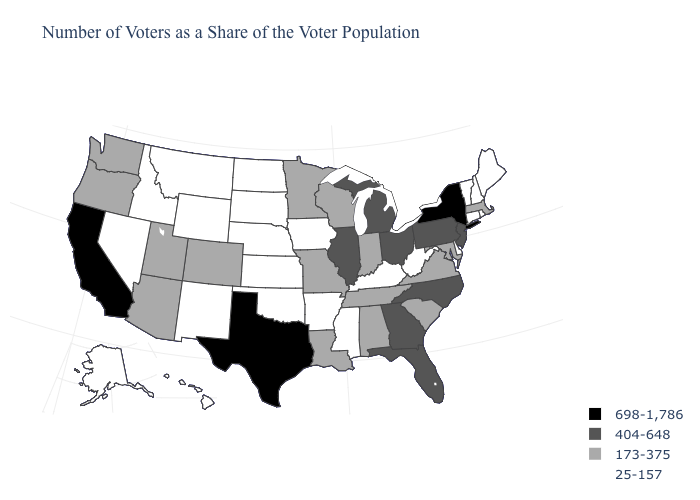Among the states that border Connecticut , which have the lowest value?
Keep it brief. Rhode Island. What is the value of Maryland?
Answer briefly. 173-375. Name the states that have a value in the range 404-648?
Quick response, please. Florida, Georgia, Illinois, Michigan, New Jersey, North Carolina, Ohio, Pennsylvania. Does Kentucky have a higher value than Iowa?
Be succinct. No. What is the highest value in the USA?
Keep it brief. 698-1,786. What is the lowest value in the Northeast?
Be succinct. 25-157. Among the states that border Arizona , which have the highest value?
Answer briefly. California. What is the highest value in states that border Oregon?
Quick response, please. 698-1,786. What is the value of Vermont?
Short answer required. 25-157. Name the states that have a value in the range 25-157?
Answer briefly. Alaska, Arkansas, Connecticut, Delaware, Hawaii, Idaho, Iowa, Kansas, Kentucky, Maine, Mississippi, Montana, Nebraska, Nevada, New Hampshire, New Mexico, North Dakota, Oklahoma, Rhode Island, South Dakota, Vermont, West Virginia, Wyoming. Does the map have missing data?
Write a very short answer. No. Does Michigan have the highest value in the MidWest?
Write a very short answer. Yes. Does Michigan have the same value as Kansas?
Concise answer only. No. What is the highest value in the Northeast ?
Keep it brief. 698-1,786. What is the highest value in states that border Pennsylvania?
Answer briefly. 698-1,786. 